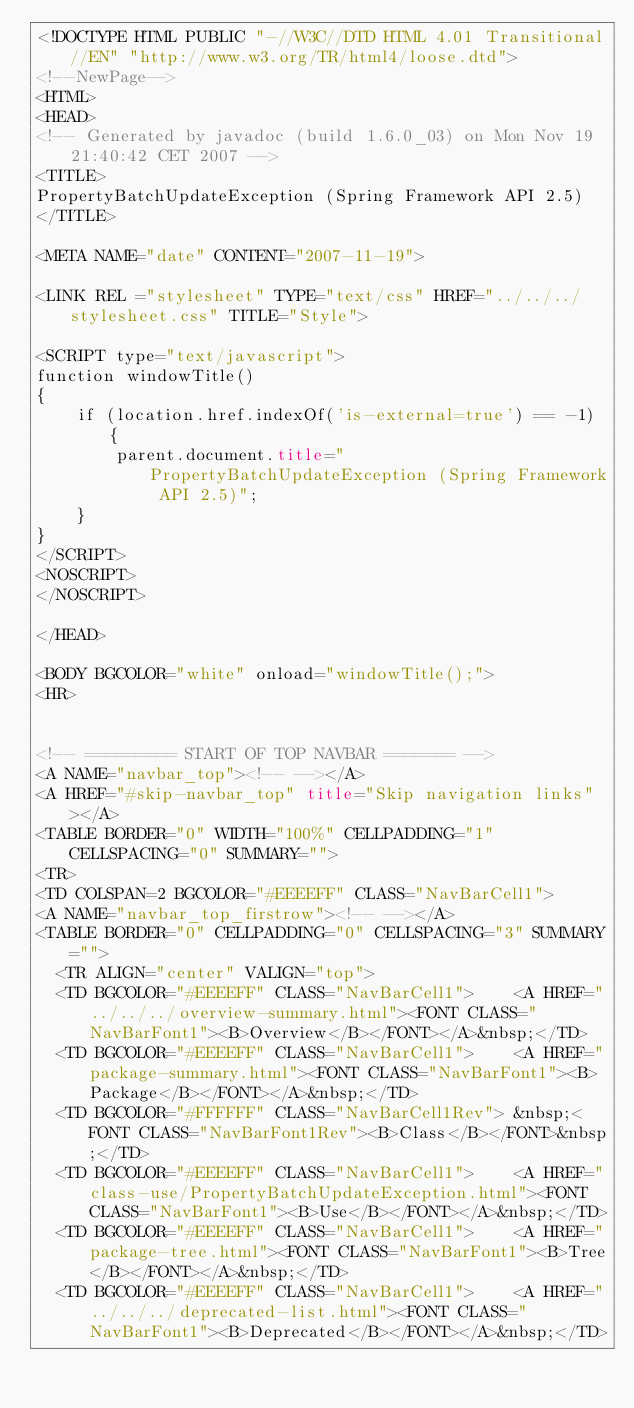<code> <loc_0><loc_0><loc_500><loc_500><_HTML_><!DOCTYPE HTML PUBLIC "-//W3C//DTD HTML 4.01 Transitional//EN" "http://www.w3.org/TR/html4/loose.dtd">
<!--NewPage-->
<HTML>
<HEAD>
<!-- Generated by javadoc (build 1.6.0_03) on Mon Nov 19 21:40:42 CET 2007 -->
<TITLE>
PropertyBatchUpdateException (Spring Framework API 2.5)
</TITLE>

<META NAME="date" CONTENT="2007-11-19">

<LINK REL ="stylesheet" TYPE="text/css" HREF="../../../stylesheet.css" TITLE="Style">

<SCRIPT type="text/javascript">
function windowTitle()
{
    if (location.href.indexOf('is-external=true') == -1) {
        parent.document.title="PropertyBatchUpdateException (Spring Framework API 2.5)";
    }
}
</SCRIPT>
<NOSCRIPT>
</NOSCRIPT>

</HEAD>

<BODY BGCOLOR="white" onload="windowTitle();">
<HR>


<!-- ========= START OF TOP NAVBAR ======= -->
<A NAME="navbar_top"><!-- --></A>
<A HREF="#skip-navbar_top" title="Skip navigation links"></A>
<TABLE BORDER="0" WIDTH="100%" CELLPADDING="1" CELLSPACING="0" SUMMARY="">
<TR>
<TD COLSPAN=2 BGCOLOR="#EEEEFF" CLASS="NavBarCell1">
<A NAME="navbar_top_firstrow"><!-- --></A>
<TABLE BORDER="0" CELLPADDING="0" CELLSPACING="3" SUMMARY="">
  <TR ALIGN="center" VALIGN="top">
  <TD BGCOLOR="#EEEEFF" CLASS="NavBarCell1">    <A HREF="../../../overview-summary.html"><FONT CLASS="NavBarFont1"><B>Overview</B></FONT></A>&nbsp;</TD>
  <TD BGCOLOR="#EEEEFF" CLASS="NavBarCell1">    <A HREF="package-summary.html"><FONT CLASS="NavBarFont1"><B>Package</B></FONT></A>&nbsp;</TD>
  <TD BGCOLOR="#FFFFFF" CLASS="NavBarCell1Rev"> &nbsp;<FONT CLASS="NavBarFont1Rev"><B>Class</B></FONT>&nbsp;</TD>
  <TD BGCOLOR="#EEEEFF" CLASS="NavBarCell1">    <A HREF="class-use/PropertyBatchUpdateException.html"><FONT CLASS="NavBarFont1"><B>Use</B></FONT></A>&nbsp;</TD>
  <TD BGCOLOR="#EEEEFF" CLASS="NavBarCell1">    <A HREF="package-tree.html"><FONT CLASS="NavBarFont1"><B>Tree</B></FONT></A>&nbsp;</TD>
  <TD BGCOLOR="#EEEEFF" CLASS="NavBarCell1">    <A HREF="../../../deprecated-list.html"><FONT CLASS="NavBarFont1"><B>Deprecated</B></FONT></A>&nbsp;</TD></code> 